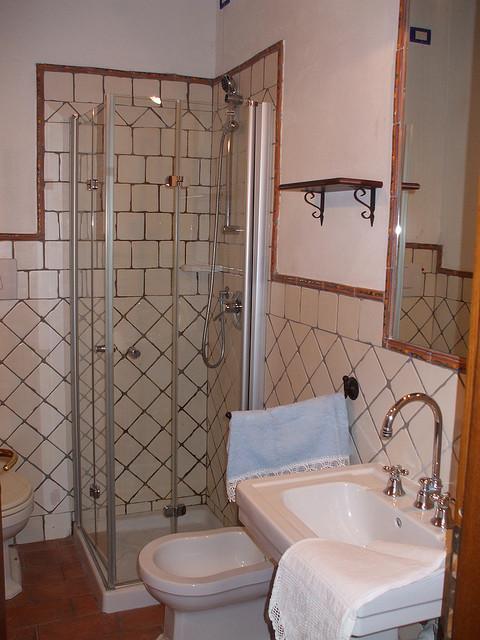How many showers are in the picture?
Give a very brief answer. 1. How many toilets are visible?
Give a very brief answer. 2. 